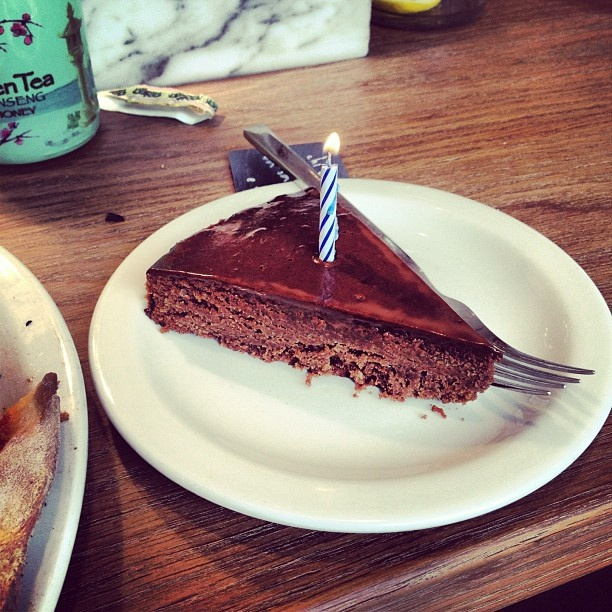Describe the objects in this image and their specific colors. I can see dining table in turquoise, beige, brown, maroon, and black tones, cake in turquoise, maroon, brown, black, and purple tones, bottle in turquoise, gray, and black tones, and fork in turquoise, gray, darkgray, and lightgray tones in this image. 